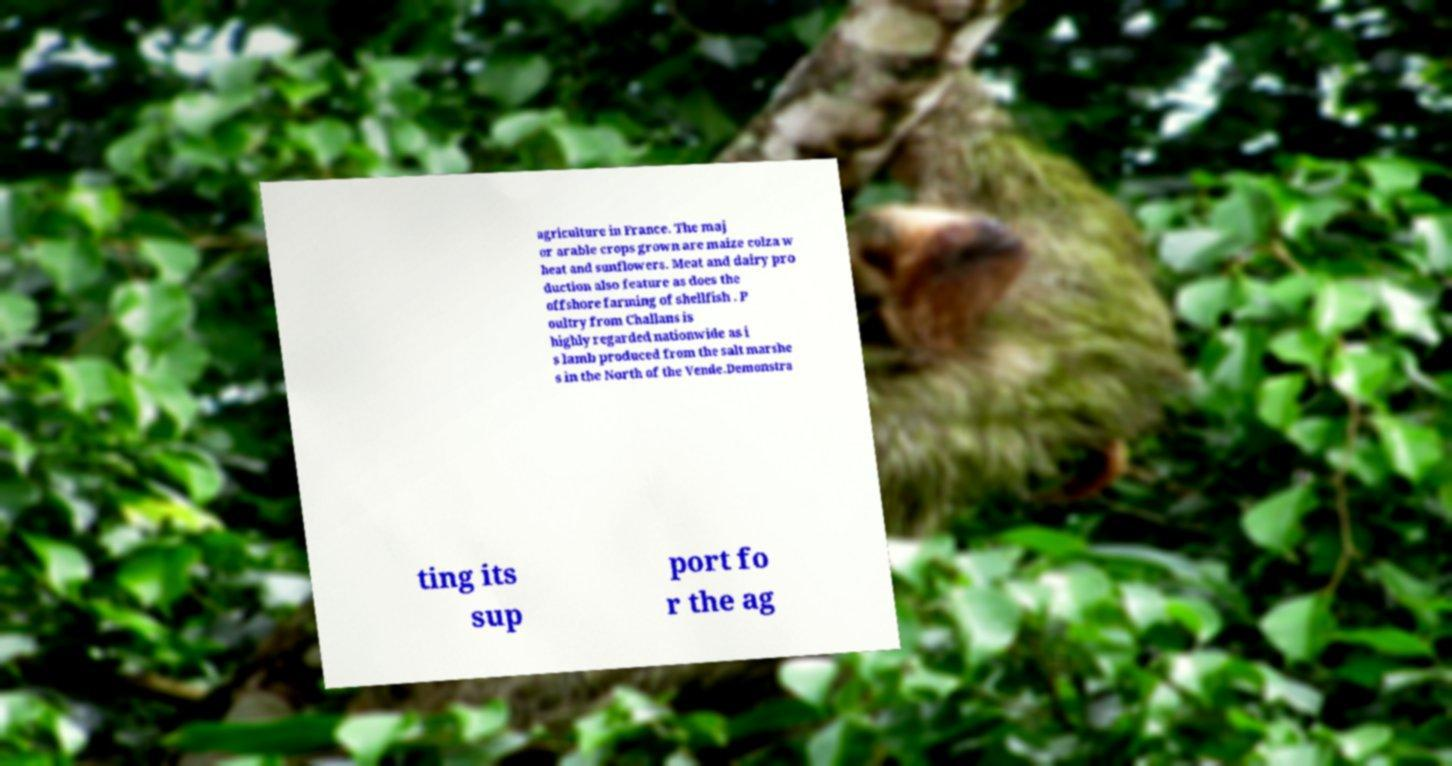For documentation purposes, I need the text within this image transcribed. Could you provide that? agriculture in France. The maj or arable crops grown are maize colza w heat and sunflowers. Meat and dairy pro duction also feature as does the offshore farming of shellfish . P oultry from Challans is highly regarded nationwide as i s lamb produced from the salt marshe s in the North of the Vende.Demonstra ting its sup port fo r the ag 